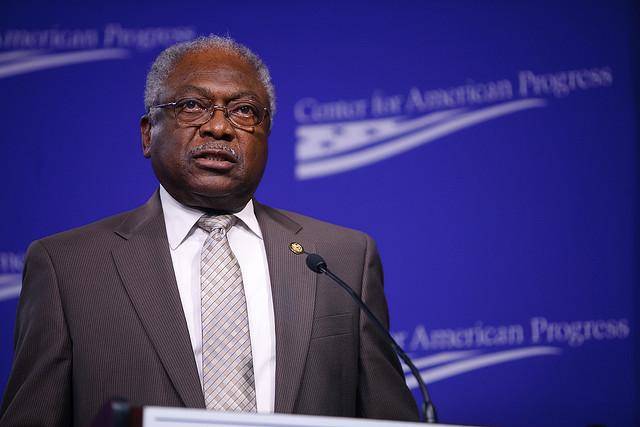Why is this man dressed up?
Quick response, please. Giving speech. What organization does he work for?
Write a very short answer. Center for american progress. Is this man happy?
Quick response, please. No. 